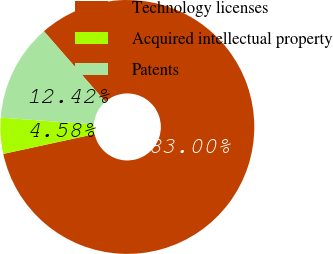<chart> <loc_0><loc_0><loc_500><loc_500><pie_chart><fcel>Technology licenses<fcel>Acquired intellectual property<fcel>Patents<nl><fcel>83.0%<fcel>4.58%<fcel>12.42%<nl></chart> 